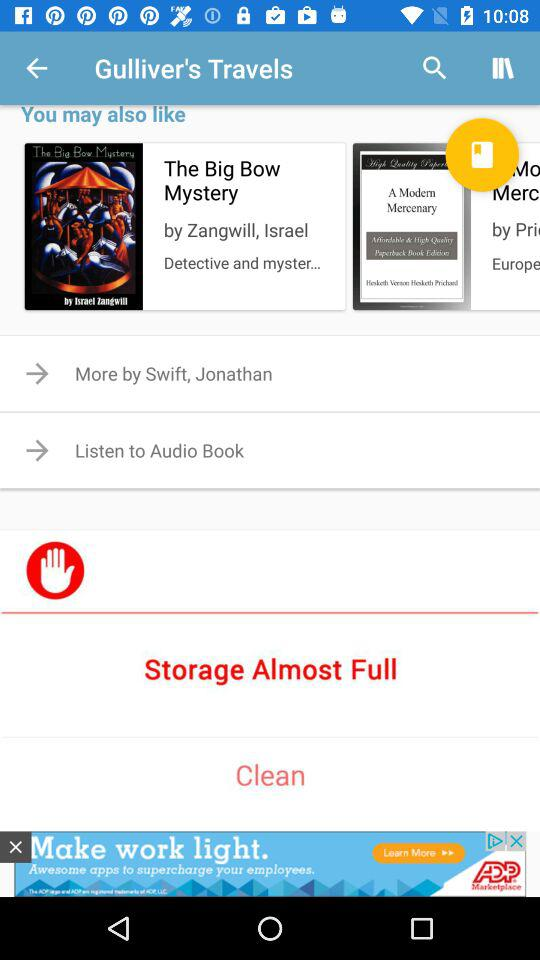What is the status of storage? The status of storage is almost full. 